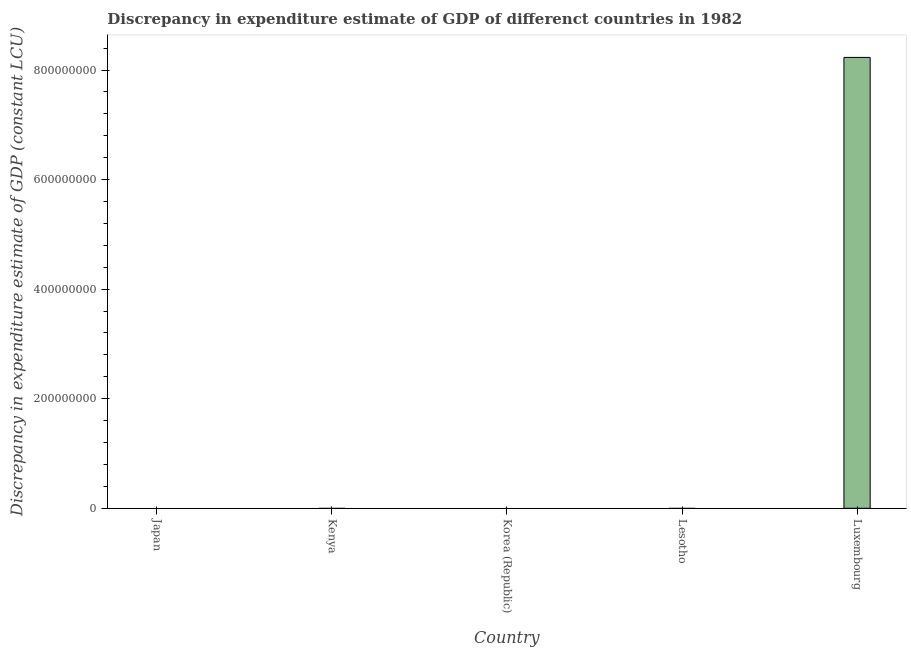Does the graph contain any zero values?
Ensure brevity in your answer.  Yes. Does the graph contain grids?
Give a very brief answer. No. What is the title of the graph?
Your answer should be compact. Discrepancy in expenditure estimate of GDP of differenct countries in 1982. What is the label or title of the Y-axis?
Give a very brief answer. Discrepancy in expenditure estimate of GDP (constant LCU). Across all countries, what is the maximum discrepancy in expenditure estimate of gdp?
Offer a very short reply. 8.23e+08. Across all countries, what is the minimum discrepancy in expenditure estimate of gdp?
Your answer should be very brief. 0. In which country was the discrepancy in expenditure estimate of gdp maximum?
Offer a terse response. Luxembourg. What is the sum of the discrepancy in expenditure estimate of gdp?
Make the answer very short. 8.23e+08. What is the average discrepancy in expenditure estimate of gdp per country?
Provide a short and direct response. 1.65e+08. What is the median discrepancy in expenditure estimate of gdp?
Your response must be concise. 0. In how many countries, is the discrepancy in expenditure estimate of gdp greater than 280000000 LCU?
Ensure brevity in your answer.  1. What is the difference between the highest and the lowest discrepancy in expenditure estimate of gdp?
Your answer should be compact. 8.23e+08. In how many countries, is the discrepancy in expenditure estimate of gdp greater than the average discrepancy in expenditure estimate of gdp taken over all countries?
Provide a succinct answer. 1. What is the difference between two consecutive major ticks on the Y-axis?
Ensure brevity in your answer.  2.00e+08. Are the values on the major ticks of Y-axis written in scientific E-notation?
Your answer should be compact. No. What is the Discrepancy in expenditure estimate of GDP (constant LCU) of Korea (Republic)?
Offer a very short reply. 0. What is the Discrepancy in expenditure estimate of GDP (constant LCU) in Luxembourg?
Make the answer very short. 8.23e+08. 